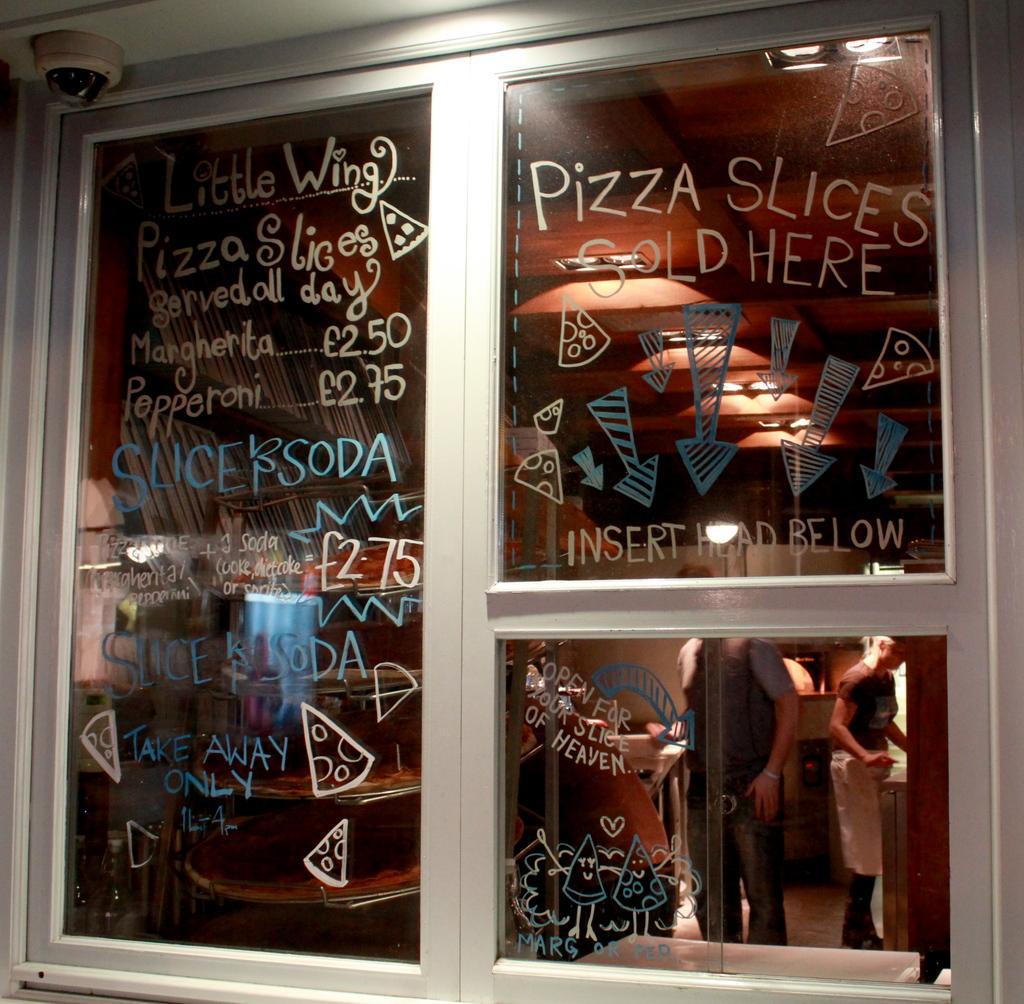In one or two sentences, can you explain what this image depicts? In the foreground of this image, there is text on a glass window. On the left top, there is a CCTV. In background, there are persons standing, tables, light to the ceiling, the wall and few books in the shelf is on the left. 